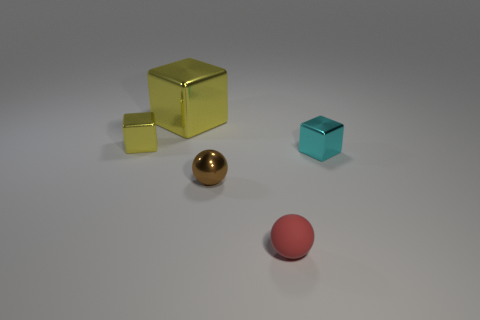What is the shape of the tiny shiny thing on the right side of the small ball that is to the right of the brown shiny thing?
Keep it short and to the point. Cube. Are there more small blocks than large cylinders?
Keep it short and to the point. Yes. How many shiny cubes are to the left of the large yellow thing and on the right side of the brown shiny ball?
Your response must be concise. 0. There is a small block to the left of the matte ball; how many tiny shiny balls are left of it?
Offer a terse response. 0. How many objects are either cyan things in front of the small yellow metallic cube or metallic blocks that are right of the big yellow metallic cube?
Offer a terse response. 1. There is another yellow object that is the same shape as the big thing; what is its material?
Ensure brevity in your answer.  Metal. What number of objects are either objects behind the tiny red rubber sphere or large cyan metal cylinders?
Your answer should be very brief. 4. There is a big thing that is the same material as the small cyan block; what is its shape?
Ensure brevity in your answer.  Cube. How many rubber things have the same shape as the large metallic thing?
Offer a terse response. 0. What is the large yellow thing made of?
Offer a very short reply. Metal. 